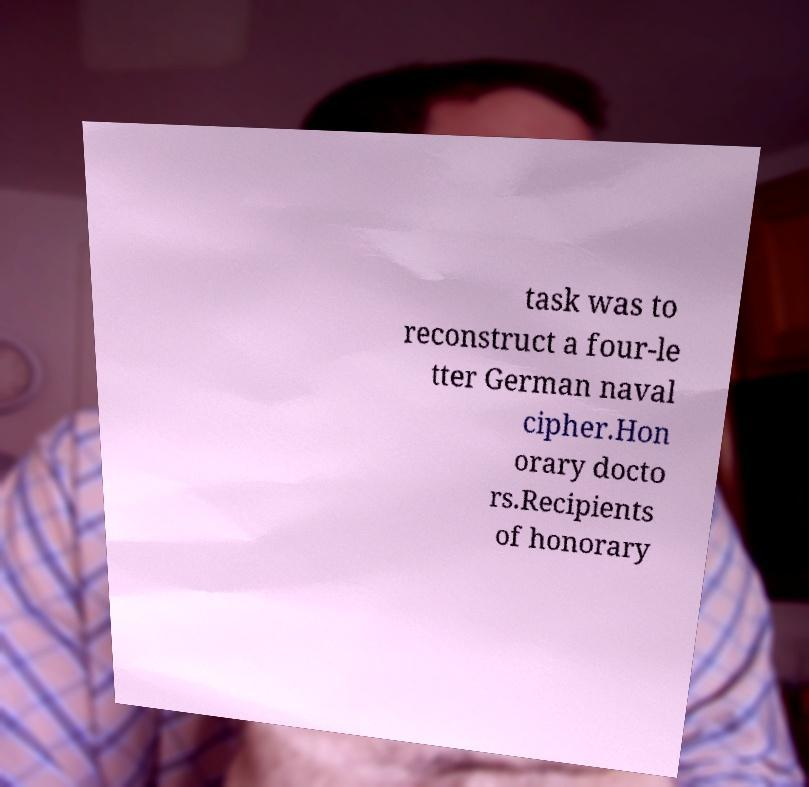Please read and relay the text visible in this image. What does it say? task was to reconstruct a four-le tter German naval cipher.Hon orary docto rs.Recipients of honorary 